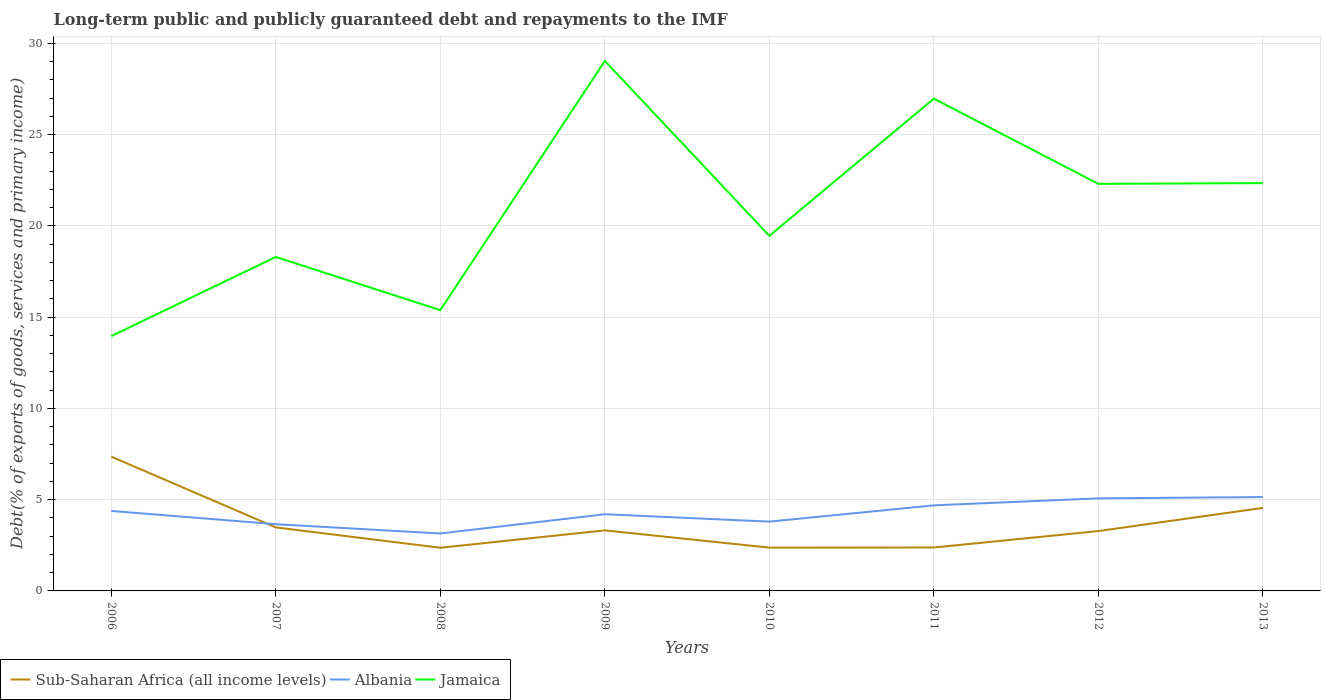Does the line corresponding to Jamaica intersect with the line corresponding to Albania?
Your response must be concise. No. Across all years, what is the maximum debt and repayments in Albania?
Keep it short and to the point. 3.15. What is the total debt and repayments in Jamaica in the graph?
Provide a short and direct response. -11.59. What is the difference between the highest and the second highest debt and repayments in Jamaica?
Make the answer very short. 15.07. Is the debt and repayments in Sub-Saharan Africa (all income levels) strictly greater than the debt and repayments in Albania over the years?
Ensure brevity in your answer.  No. How many lines are there?
Provide a short and direct response. 3. Are the values on the major ticks of Y-axis written in scientific E-notation?
Ensure brevity in your answer.  No. Does the graph contain any zero values?
Provide a succinct answer. No. Does the graph contain grids?
Your answer should be compact. Yes. How many legend labels are there?
Ensure brevity in your answer.  3. What is the title of the graph?
Provide a succinct answer. Long-term public and publicly guaranteed debt and repayments to the IMF. What is the label or title of the Y-axis?
Your answer should be very brief. Debt(% of exports of goods, services and primary income). What is the Debt(% of exports of goods, services and primary income) of Sub-Saharan Africa (all income levels) in 2006?
Make the answer very short. 7.35. What is the Debt(% of exports of goods, services and primary income) in Albania in 2006?
Your answer should be compact. 4.38. What is the Debt(% of exports of goods, services and primary income) in Jamaica in 2006?
Your answer should be compact. 13.96. What is the Debt(% of exports of goods, services and primary income) in Sub-Saharan Africa (all income levels) in 2007?
Give a very brief answer. 3.48. What is the Debt(% of exports of goods, services and primary income) in Albania in 2007?
Keep it short and to the point. 3.66. What is the Debt(% of exports of goods, services and primary income) of Jamaica in 2007?
Provide a succinct answer. 18.29. What is the Debt(% of exports of goods, services and primary income) of Sub-Saharan Africa (all income levels) in 2008?
Your answer should be compact. 2.36. What is the Debt(% of exports of goods, services and primary income) in Albania in 2008?
Provide a succinct answer. 3.15. What is the Debt(% of exports of goods, services and primary income) in Jamaica in 2008?
Your answer should be very brief. 15.38. What is the Debt(% of exports of goods, services and primary income) in Sub-Saharan Africa (all income levels) in 2009?
Keep it short and to the point. 3.32. What is the Debt(% of exports of goods, services and primary income) of Albania in 2009?
Make the answer very short. 4.2. What is the Debt(% of exports of goods, services and primary income) in Jamaica in 2009?
Your response must be concise. 29.03. What is the Debt(% of exports of goods, services and primary income) in Sub-Saharan Africa (all income levels) in 2010?
Offer a very short reply. 2.37. What is the Debt(% of exports of goods, services and primary income) of Albania in 2010?
Provide a succinct answer. 3.8. What is the Debt(% of exports of goods, services and primary income) in Jamaica in 2010?
Your response must be concise. 19.45. What is the Debt(% of exports of goods, services and primary income) of Sub-Saharan Africa (all income levels) in 2011?
Keep it short and to the point. 2.38. What is the Debt(% of exports of goods, services and primary income) of Albania in 2011?
Your answer should be very brief. 4.69. What is the Debt(% of exports of goods, services and primary income) in Jamaica in 2011?
Your answer should be compact. 26.97. What is the Debt(% of exports of goods, services and primary income) of Sub-Saharan Africa (all income levels) in 2012?
Ensure brevity in your answer.  3.28. What is the Debt(% of exports of goods, services and primary income) of Albania in 2012?
Your answer should be very brief. 5.07. What is the Debt(% of exports of goods, services and primary income) of Jamaica in 2012?
Provide a succinct answer. 22.3. What is the Debt(% of exports of goods, services and primary income) in Sub-Saharan Africa (all income levels) in 2013?
Keep it short and to the point. 4.55. What is the Debt(% of exports of goods, services and primary income) in Albania in 2013?
Ensure brevity in your answer.  5.14. What is the Debt(% of exports of goods, services and primary income) in Jamaica in 2013?
Offer a terse response. 22.34. Across all years, what is the maximum Debt(% of exports of goods, services and primary income) in Sub-Saharan Africa (all income levels)?
Ensure brevity in your answer.  7.35. Across all years, what is the maximum Debt(% of exports of goods, services and primary income) of Albania?
Ensure brevity in your answer.  5.14. Across all years, what is the maximum Debt(% of exports of goods, services and primary income) in Jamaica?
Make the answer very short. 29.03. Across all years, what is the minimum Debt(% of exports of goods, services and primary income) of Sub-Saharan Africa (all income levels)?
Ensure brevity in your answer.  2.36. Across all years, what is the minimum Debt(% of exports of goods, services and primary income) of Albania?
Keep it short and to the point. 3.15. Across all years, what is the minimum Debt(% of exports of goods, services and primary income) in Jamaica?
Your answer should be compact. 13.96. What is the total Debt(% of exports of goods, services and primary income) of Sub-Saharan Africa (all income levels) in the graph?
Make the answer very short. 29.09. What is the total Debt(% of exports of goods, services and primary income) of Albania in the graph?
Provide a succinct answer. 34.08. What is the total Debt(% of exports of goods, services and primary income) in Jamaica in the graph?
Offer a terse response. 167.72. What is the difference between the Debt(% of exports of goods, services and primary income) of Sub-Saharan Africa (all income levels) in 2006 and that in 2007?
Your answer should be very brief. 3.88. What is the difference between the Debt(% of exports of goods, services and primary income) in Albania in 2006 and that in 2007?
Provide a succinct answer. 0.73. What is the difference between the Debt(% of exports of goods, services and primary income) in Jamaica in 2006 and that in 2007?
Give a very brief answer. -4.34. What is the difference between the Debt(% of exports of goods, services and primary income) in Sub-Saharan Africa (all income levels) in 2006 and that in 2008?
Give a very brief answer. 4.99. What is the difference between the Debt(% of exports of goods, services and primary income) in Albania in 2006 and that in 2008?
Make the answer very short. 1.23. What is the difference between the Debt(% of exports of goods, services and primary income) in Jamaica in 2006 and that in 2008?
Provide a short and direct response. -1.42. What is the difference between the Debt(% of exports of goods, services and primary income) of Sub-Saharan Africa (all income levels) in 2006 and that in 2009?
Your response must be concise. 4.04. What is the difference between the Debt(% of exports of goods, services and primary income) in Albania in 2006 and that in 2009?
Offer a very short reply. 0.18. What is the difference between the Debt(% of exports of goods, services and primary income) in Jamaica in 2006 and that in 2009?
Ensure brevity in your answer.  -15.07. What is the difference between the Debt(% of exports of goods, services and primary income) of Sub-Saharan Africa (all income levels) in 2006 and that in 2010?
Provide a succinct answer. 4.98. What is the difference between the Debt(% of exports of goods, services and primary income) of Albania in 2006 and that in 2010?
Your answer should be compact. 0.58. What is the difference between the Debt(% of exports of goods, services and primary income) of Jamaica in 2006 and that in 2010?
Your response must be concise. -5.49. What is the difference between the Debt(% of exports of goods, services and primary income) of Sub-Saharan Africa (all income levels) in 2006 and that in 2011?
Make the answer very short. 4.98. What is the difference between the Debt(% of exports of goods, services and primary income) of Albania in 2006 and that in 2011?
Give a very brief answer. -0.31. What is the difference between the Debt(% of exports of goods, services and primary income) of Jamaica in 2006 and that in 2011?
Offer a terse response. -13.01. What is the difference between the Debt(% of exports of goods, services and primary income) in Sub-Saharan Africa (all income levels) in 2006 and that in 2012?
Offer a very short reply. 4.07. What is the difference between the Debt(% of exports of goods, services and primary income) in Albania in 2006 and that in 2012?
Offer a terse response. -0.69. What is the difference between the Debt(% of exports of goods, services and primary income) of Jamaica in 2006 and that in 2012?
Give a very brief answer. -8.34. What is the difference between the Debt(% of exports of goods, services and primary income) of Sub-Saharan Africa (all income levels) in 2006 and that in 2013?
Provide a succinct answer. 2.81. What is the difference between the Debt(% of exports of goods, services and primary income) of Albania in 2006 and that in 2013?
Your answer should be compact. -0.76. What is the difference between the Debt(% of exports of goods, services and primary income) in Jamaica in 2006 and that in 2013?
Ensure brevity in your answer.  -8.38. What is the difference between the Debt(% of exports of goods, services and primary income) of Sub-Saharan Africa (all income levels) in 2007 and that in 2008?
Your response must be concise. 1.11. What is the difference between the Debt(% of exports of goods, services and primary income) of Albania in 2007 and that in 2008?
Your response must be concise. 0.51. What is the difference between the Debt(% of exports of goods, services and primary income) in Jamaica in 2007 and that in 2008?
Give a very brief answer. 2.91. What is the difference between the Debt(% of exports of goods, services and primary income) in Sub-Saharan Africa (all income levels) in 2007 and that in 2009?
Keep it short and to the point. 0.16. What is the difference between the Debt(% of exports of goods, services and primary income) in Albania in 2007 and that in 2009?
Make the answer very short. -0.55. What is the difference between the Debt(% of exports of goods, services and primary income) in Jamaica in 2007 and that in 2009?
Give a very brief answer. -10.74. What is the difference between the Debt(% of exports of goods, services and primary income) of Sub-Saharan Africa (all income levels) in 2007 and that in 2010?
Make the answer very short. 1.11. What is the difference between the Debt(% of exports of goods, services and primary income) of Albania in 2007 and that in 2010?
Provide a short and direct response. -0.14. What is the difference between the Debt(% of exports of goods, services and primary income) of Jamaica in 2007 and that in 2010?
Keep it short and to the point. -1.15. What is the difference between the Debt(% of exports of goods, services and primary income) of Sub-Saharan Africa (all income levels) in 2007 and that in 2011?
Your answer should be very brief. 1.1. What is the difference between the Debt(% of exports of goods, services and primary income) in Albania in 2007 and that in 2011?
Keep it short and to the point. -1.03. What is the difference between the Debt(% of exports of goods, services and primary income) of Jamaica in 2007 and that in 2011?
Offer a terse response. -8.67. What is the difference between the Debt(% of exports of goods, services and primary income) of Sub-Saharan Africa (all income levels) in 2007 and that in 2012?
Your answer should be very brief. 0.2. What is the difference between the Debt(% of exports of goods, services and primary income) in Albania in 2007 and that in 2012?
Your answer should be very brief. -1.42. What is the difference between the Debt(% of exports of goods, services and primary income) in Jamaica in 2007 and that in 2012?
Ensure brevity in your answer.  -4. What is the difference between the Debt(% of exports of goods, services and primary income) of Sub-Saharan Africa (all income levels) in 2007 and that in 2013?
Ensure brevity in your answer.  -1.07. What is the difference between the Debt(% of exports of goods, services and primary income) in Albania in 2007 and that in 2013?
Your answer should be compact. -1.49. What is the difference between the Debt(% of exports of goods, services and primary income) of Jamaica in 2007 and that in 2013?
Offer a very short reply. -4.05. What is the difference between the Debt(% of exports of goods, services and primary income) of Sub-Saharan Africa (all income levels) in 2008 and that in 2009?
Keep it short and to the point. -0.95. What is the difference between the Debt(% of exports of goods, services and primary income) of Albania in 2008 and that in 2009?
Give a very brief answer. -1.05. What is the difference between the Debt(% of exports of goods, services and primary income) in Jamaica in 2008 and that in 2009?
Offer a terse response. -13.65. What is the difference between the Debt(% of exports of goods, services and primary income) in Sub-Saharan Africa (all income levels) in 2008 and that in 2010?
Your response must be concise. -0.01. What is the difference between the Debt(% of exports of goods, services and primary income) of Albania in 2008 and that in 2010?
Make the answer very short. -0.65. What is the difference between the Debt(% of exports of goods, services and primary income) in Jamaica in 2008 and that in 2010?
Offer a very short reply. -4.07. What is the difference between the Debt(% of exports of goods, services and primary income) in Sub-Saharan Africa (all income levels) in 2008 and that in 2011?
Your answer should be very brief. -0.01. What is the difference between the Debt(% of exports of goods, services and primary income) of Albania in 2008 and that in 2011?
Give a very brief answer. -1.54. What is the difference between the Debt(% of exports of goods, services and primary income) of Jamaica in 2008 and that in 2011?
Keep it short and to the point. -11.59. What is the difference between the Debt(% of exports of goods, services and primary income) of Sub-Saharan Africa (all income levels) in 2008 and that in 2012?
Make the answer very short. -0.91. What is the difference between the Debt(% of exports of goods, services and primary income) in Albania in 2008 and that in 2012?
Your answer should be compact. -1.92. What is the difference between the Debt(% of exports of goods, services and primary income) of Jamaica in 2008 and that in 2012?
Provide a succinct answer. -6.92. What is the difference between the Debt(% of exports of goods, services and primary income) of Sub-Saharan Africa (all income levels) in 2008 and that in 2013?
Your response must be concise. -2.18. What is the difference between the Debt(% of exports of goods, services and primary income) of Albania in 2008 and that in 2013?
Provide a succinct answer. -1.99. What is the difference between the Debt(% of exports of goods, services and primary income) of Jamaica in 2008 and that in 2013?
Provide a succinct answer. -6.96. What is the difference between the Debt(% of exports of goods, services and primary income) of Sub-Saharan Africa (all income levels) in 2009 and that in 2010?
Give a very brief answer. 0.95. What is the difference between the Debt(% of exports of goods, services and primary income) in Albania in 2009 and that in 2010?
Provide a short and direct response. 0.4. What is the difference between the Debt(% of exports of goods, services and primary income) in Jamaica in 2009 and that in 2010?
Offer a very short reply. 9.58. What is the difference between the Debt(% of exports of goods, services and primary income) of Sub-Saharan Africa (all income levels) in 2009 and that in 2011?
Offer a terse response. 0.94. What is the difference between the Debt(% of exports of goods, services and primary income) of Albania in 2009 and that in 2011?
Give a very brief answer. -0.49. What is the difference between the Debt(% of exports of goods, services and primary income) in Jamaica in 2009 and that in 2011?
Your response must be concise. 2.07. What is the difference between the Debt(% of exports of goods, services and primary income) of Sub-Saharan Africa (all income levels) in 2009 and that in 2012?
Keep it short and to the point. 0.04. What is the difference between the Debt(% of exports of goods, services and primary income) of Albania in 2009 and that in 2012?
Your response must be concise. -0.87. What is the difference between the Debt(% of exports of goods, services and primary income) of Jamaica in 2009 and that in 2012?
Your answer should be compact. 6.73. What is the difference between the Debt(% of exports of goods, services and primary income) in Sub-Saharan Africa (all income levels) in 2009 and that in 2013?
Provide a short and direct response. -1.23. What is the difference between the Debt(% of exports of goods, services and primary income) in Albania in 2009 and that in 2013?
Give a very brief answer. -0.94. What is the difference between the Debt(% of exports of goods, services and primary income) of Jamaica in 2009 and that in 2013?
Your response must be concise. 6.69. What is the difference between the Debt(% of exports of goods, services and primary income) in Sub-Saharan Africa (all income levels) in 2010 and that in 2011?
Offer a terse response. -0.01. What is the difference between the Debt(% of exports of goods, services and primary income) in Albania in 2010 and that in 2011?
Make the answer very short. -0.89. What is the difference between the Debt(% of exports of goods, services and primary income) in Jamaica in 2010 and that in 2011?
Make the answer very short. -7.52. What is the difference between the Debt(% of exports of goods, services and primary income) of Sub-Saharan Africa (all income levels) in 2010 and that in 2012?
Your response must be concise. -0.91. What is the difference between the Debt(% of exports of goods, services and primary income) of Albania in 2010 and that in 2012?
Provide a short and direct response. -1.27. What is the difference between the Debt(% of exports of goods, services and primary income) in Jamaica in 2010 and that in 2012?
Offer a very short reply. -2.85. What is the difference between the Debt(% of exports of goods, services and primary income) in Sub-Saharan Africa (all income levels) in 2010 and that in 2013?
Your response must be concise. -2.18. What is the difference between the Debt(% of exports of goods, services and primary income) of Albania in 2010 and that in 2013?
Offer a very short reply. -1.35. What is the difference between the Debt(% of exports of goods, services and primary income) in Jamaica in 2010 and that in 2013?
Your answer should be very brief. -2.89. What is the difference between the Debt(% of exports of goods, services and primary income) of Sub-Saharan Africa (all income levels) in 2011 and that in 2012?
Make the answer very short. -0.9. What is the difference between the Debt(% of exports of goods, services and primary income) of Albania in 2011 and that in 2012?
Provide a succinct answer. -0.38. What is the difference between the Debt(% of exports of goods, services and primary income) in Jamaica in 2011 and that in 2012?
Keep it short and to the point. 4.67. What is the difference between the Debt(% of exports of goods, services and primary income) in Sub-Saharan Africa (all income levels) in 2011 and that in 2013?
Keep it short and to the point. -2.17. What is the difference between the Debt(% of exports of goods, services and primary income) in Albania in 2011 and that in 2013?
Your answer should be compact. -0.45. What is the difference between the Debt(% of exports of goods, services and primary income) in Jamaica in 2011 and that in 2013?
Ensure brevity in your answer.  4.62. What is the difference between the Debt(% of exports of goods, services and primary income) in Sub-Saharan Africa (all income levels) in 2012 and that in 2013?
Your response must be concise. -1.27. What is the difference between the Debt(% of exports of goods, services and primary income) in Albania in 2012 and that in 2013?
Provide a succinct answer. -0.07. What is the difference between the Debt(% of exports of goods, services and primary income) in Jamaica in 2012 and that in 2013?
Your response must be concise. -0.04. What is the difference between the Debt(% of exports of goods, services and primary income) in Sub-Saharan Africa (all income levels) in 2006 and the Debt(% of exports of goods, services and primary income) in Albania in 2007?
Offer a terse response. 3.7. What is the difference between the Debt(% of exports of goods, services and primary income) of Sub-Saharan Africa (all income levels) in 2006 and the Debt(% of exports of goods, services and primary income) of Jamaica in 2007?
Keep it short and to the point. -10.94. What is the difference between the Debt(% of exports of goods, services and primary income) in Albania in 2006 and the Debt(% of exports of goods, services and primary income) in Jamaica in 2007?
Offer a very short reply. -13.91. What is the difference between the Debt(% of exports of goods, services and primary income) in Sub-Saharan Africa (all income levels) in 2006 and the Debt(% of exports of goods, services and primary income) in Albania in 2008?
Your answer should be compact. 4.21. What is the difference between the Debt(% of exports of goods, services and primary income) of Sub-Saharan Africa (all income levels) in 2006 and the Debt(% of exports of goods, services and primary income) of Jamaica in 2008?
Keep it short and to the point. -8.03. What is the difference between the Debt(% of exports of goods, services and primary income) in Albania in 2006 and the Debt(% of exports of goods, services and primary income) in Jamaica in 2008?
Your answer should be very brief. -11. What is the difference between the Debt(% of exports of goods, services and primary income) in Sub-Saharan Africa (all income levels) in 2006 and the Debt(% of exports of goods, services and primary income) in Albania in 2009?
Offer a terse response. 3.15. What is the difference between the Debt(% of exports of goods, services and primary income) of Sub-Saharan Africa (all income levels) in 2006 and the Debt(% of exports of goods, services and primary income) of Jamaica in 2009?
Offer a terse response. -21.68. What is the difference between the Debt(% of exports of goods, services and primary income) in Albania in 2006 and the Debt(% of exports of goods, services and primary income) in Jamaica in 2009?
Your response must be concise. -24.65. What is the difference between the Debt(% of exports of goods, services and primary income) of Sub-Saharan Africa (all income levels) in 2006 and the Debt(% of exports of goods, services and primary income) of Albania in 2010?
Offer a terse response. 3.56. What is the difference between the Debt(% of exports of goods, services and primary income) of Sub-Saharan Africa (all income levels) in 2006 and the Debt(% of exports of goods, services and primary income) of Jamaica in 2010?
Make the answer very short. -12.1. What is the difference between the Debt(% of exports of goods, services and primary income) in Albania in 2006 and the Debt(% of exports of goods, services and primary income) in Jamaica in 2010?
Make the answer very short. -15.07. What is the difference between the Debt(% of exports of goods, services and primary income) of Sub-Saharan Africa (all income levels) in 2006 and the Debt(% of exports of goods, services and primary income) of Albania in 2011?
Make the answer very short. 2.67. What is the difference between the Debt(% of exports of goods, services and primary income) in Sub-Saharan Africa (all income levels) in 2006 and the Debt(% of exports of goods, services and primary income) in Jamaica in 2011?
Provide a short and direct response. -19.61. What is the difference between the Debt(% of exports of goods, services and primary income) of Albania in 2006 and the Debt(% of exports of goods, services and primary income) of Jamaica in 2011?
Your answer should be compact. -22.59. What is the difference between the Debt(% of exports of goods, services and primary income) in Sub-Saharan Africa (all income levels) in 2006 and the Debt(% of exports of goods, services and primary income) in Albania in 2012?
Make the answer very short. 2.28. What is the difference between the Debt(% of exports of goods, services and primary income) of Sub-Saharan Africa (all income levels) in 2006 and the Debt(% of exports of goods, services and primary income) of Jamaica in 2012?
Ensure brevity in your answer.  -14.94. What is the difference between the Debt(% of exports of goods, services and primary income) of Albania in 2006 and the Debt(% of exports of goods, services and primary income) of Jamaica in 2012?
Provide a short and direct response. -17.92. What is the difference between the Debt(% of exports of goods, services and primary income) in Sub-Saharan Africa (all income levels) in 2006 and the Debt(% of exports of goods, services and primary income) in Albania in 2013?
Give a very brief answer. 2.21. What is the difference between the Debt(% of exports of goods, services and primary income) in Sub-Saharan Africa (all income levels) in 2006 and the Debt(% of exports of goods, services and primary income) in Jamaica in 2013?
Provide a succinct answer. -14.99. What is the difference between the Debt(% of exports of goods, services and primary income) of Albania in 2006 and the Debt(% of exports of goods, services and primary income) of Jamaica in 2013?
Make the answer very short. -17.96. What is the difference between the Debt(% of exports of goods, services and primary income) in Sub-Saharan Africa (all income levels) in 2007 and the Debt(% of exports of goods, services and primary income) in Albania in 2008?
Your answer should be very brief. 0.33. What is the difference between the Debt(% of exports of goods, services and primary income) in Sub-Saharan Africa (all income levels) in 2007 and the Debt(% of exports of goods, services and primary income) in Jamaica in 2008?
Make the answer very short. -11.9. What is the difference between the Debt(% of exports of goods, services and primary income) of Albania in 2007 and the Debt(% of exports of goods, services and primary income) of Jamaica in 2008?
Offer a terse response. -11.72. What is the difference between the Debt(% of exports of goods, services and primary income) of Sub-Saharan Africa (all income levels) in 2007 and the Debt(% of exports of goods, services and primary income) of Albania in 2009?
Make the answer very short. -0.72. What is the difference between the Debt(% of exports of goods, services and primary income) in Sub-Saharan Africa (all income levels) in 2007 and the Debt(% of exports of goods, services and primary income) in Jamaica in 2009?
Offer a very short reply. -25.55. What is the difference between the Debt(% of exports of goods, services and primary income) of Albania in 2007 and the Debt(% of exports of goods, services and primary income) of Jamaica in 2009?
Offer a very short reply. -25.38. What is the difference between the Debt(% of exports of goods, services and primary income) in Sub-Saharan Africa (all income levels) in 2007 and the Debt(% of exports of goods, services and primary income) in Albania in 2010?
Give a very brief answer. -0.32. What is the difference between the Debt(% of exports of goods, services and primary income) in Sub-Saharan Africa (all income levels) in 2007 and the Debt(% of exports of goods, services and primary income) in Jamaica in 2010?
Offer a very short reply. -15.97. What is the difference between the Debt(% of exports of goods, services and primary income) in Albania in 2007 and the Debt(% of exports of goods, services and primary income) in Jamaica in 2010?
Give a very brief answer. -15.79. What is the difference between the Debt(% of exports of goods, services and primary income) in Sub-Saharan Africa (all income levels) in 2007 and the Debt(% of exports of goods, services and primary income) in Albania in 2011?
Offer a terse response. -1.21. What is the difference between the Debt(% of exports of goods, services and primary income) in Sub-Saharan Africa (all income levels) in 2007 and the Debt(% of exports of goods, services and primary income) in Jamaica in 2011?
Your answer should be compact. -23.49. What is the difference between the Debt(% of exports of goods, services and primary income) of Albania in 2007 and the Debt(% of exports of goods, services and primary income) of Jamaica in 2011?
Keep it short and to the point. -23.31. What is the difference between the Debt(% of exports of goods, services and primary income) in Sub-Saharan Africa (all income levels) in 2007 and the Debt(% of exports of goods, services and primary income) in Albania in 2012?
Give a very brief answer. -1.59. What is the difference between the Debt(% of exports of goods, services and primary income) in Sub-Saharan Africa (all income levels) in 2007 and the Debt(% of exports of goods, services and primary income) in Jamaica in 2012?
Make the answer very short. -18.82. What is the difference between the Debt(% of exports of goods, services and primary income) of Albania in 2007 and the Debt(% of exports of goods, services and primary income) of Jamaica in 2012?
Your answer should be compact. -18.64. What is the difference between the Debt(% of exports of goods, services and primary income) of Sub-Saharan Africa (all income levels) in 2007 and the Debt(% of exports of goods, services and primary income) of Albania in 2013?
Your answer should be very brief. -1.66. What is the difference between the Debt(% of exports of goods, services and primary income) in Sub-Saharan Africa (all income levels) in 2007 and the Debt(% of exports of goods, services and primary income) in Jamaica in 2013?
Provide a short and direct response. -18.86. What is the difference between the Debt(% of exports of goods, services and primary income) of Albania in 2007 and the Debt(% of exports of goods, services and primary income) of Jamaica in 2013?
Ensure brevity in your answer.  -18.69. What is the difference between the Debt(% of exports of goods, services and primary income) of Sub-Saharan Africa (all income levels) in 2008 and the Debt(% of exports of goods, services and primary income) of Albania in 2009?
Provide a short and direct response. -1.84. What is the difference between the Debt(% of exports of goods, services and primary income) in Sub-Saharan Africa (all income levels) in 2008 and the Debt(% of exports of goods, services and primary income) in Jamaica in 2009?
Keep it short and to the point. -26.67. What is the difference between the Debt(% of exports of goods, services and primary income) in Albania in 2008 and the Debt(% of exports of goods, services and primary income) in Jamaica in 2009?
Ensure brevity in your answer.  -25.89. What is the difference between the Debt(% of exports of goods, services and primary income) of Sub-Saharan Africa (all income levels) in 2008 and the Debt(% of exports of goods, services and primary income) of Albania in 2010?
Offer a very short reply. -1.43. What is the difference between the Debt(% of exports of goods, services and primary income) in Sub-Saharan Africa (all income levels) in 2008 and the Debt(% of exports of goods, services and primary income) in Jamaica in 2010?
Ensure brevity in your answer.  -17.09. What is the difference between the Debt(% of exports of goods, services and primary income) of Albania in 2008 and the Debt(% of exports of goods, services and primary income) of Jamaica in 2010?
Offer a terse response. -16.3. What is the difference between the Debt(% of exports of goods, services and primary income) of Sub-Saharan Africa (all income levels) in 2008 and the Debt(% of exports of goods, services and primary income) of Albania in 2011?
Give a very brief answer. -2.32. What is the difference between the Debt(% of exports of goods, services and primary income) of Sub-Saharan Africa (all income levels) in 2008 and the Debt(% of exports of goods, services and primary income) of Jamaica in 2011?
Your answer should be compact. -24.6. What is the difference between the Debt(% of exports of goods, services and primary income) in Albania in 2008 and the Debt(% of exports of goods, services and primary income) in Jamaica in 2011?
Offer a terse response. -23.82. What is the difference between the Debt(% of exports of goods, services and primary income) in Sub-Saharan Africa (all income levels) in 2008 and the Debt(% of exports of goods, services and primary income) in Albania in 2012?
Your answer should be compact. -2.71. What is the difference between the Debt(% of exports of goods, services and primary income) in Sub-Saharan Africa (all income levels) in 2008 and the Debt(% of exports of goods, services and primary income) in Jamaica in 2012?
Provide a short and direct response. -19.93. What is the difference between the Debt(% of exports of goods, services and primary income) of Albania in 2008 and the Debt(% of exports of goods, services and primary income) of Jamaica in 2012?
Ensure brevity in your answer.  -19.15. What is the difference between the Debt(% of exports of goods, services and primary income) of Sub-Saharan Africa (all income levels) in 2008 and the Debt(% of exports of goods, services and primary income) of Albania in 2013?
Your response must be concise. -2.78. What is the difference between the Debt(% of exports of goods, services and primary income) of Sub-Saharan Africa (all income levels) in 2008 and the Debt(% of exports of goods, services and primary income) of Jamaica in 2013?
Give a very brief answer. -19.98. What is the difference between the Debt(% of exports of goods, services and primary income) in Albania in 2008 and the Debt(% of exports of goods, services and primary income) in Jamaica in 2013?
Your response must be concise. -19.19. What is the difference between the Debt(% of exports of goods, services and primary income) of Sub-Saharan Africa (all income levels) in 2009 and the Debt(% of exports of goods, services and primary income) of Albania in 2010?
Offer a very short reply. -0.48. What is the difference between the Debt(% of exports of goods, services and primary income) of Sub-Saharan Africa (all income levels) in 2009 and the Debt(% of exports of goods, services and primary income) of Jamaica in 2010?
Keep it short and to the point. -16.13. What is the difference between the Debt(% of exports of goods, services and primary income) in Albania in 2009 and the Debt(% of exports of goods, services and primary income) in Jamaica in 2010?
Your answer should be very brief. -15.25. What is the difference between the Debt(% of exports of goods, services and primary income) in Sub-Saharan Africa (all income levels) in 2009 and the Debt(% of exports of goods, services and primary income) in Albania in 2011?
Keep it short and to the point. -1.37. What is the difference between the Debt(% of exports of goods, services and primary income) of Sub-Saharan Africa (all income levels) in 2009 and the Debt(% of exports of goods, services and primary income) of Jamaica in 2011?
Your answer should be very brief. -23.65. What is the difference between the Debt(% of exports of goods, services and primary income) of Albania in 2009 and the Debt(% of exports of goods, services and primary income) of Jamaica in 2011?
Your response must be concise. -22.77. What is the difference between the Debt(% of exports of goods, services and primary income) in Sub-Saharan Africa (all income levels) in 2009 and the Debt(% of exports of goods, services and primary income) in Albania in 2012?
Ensure brevity in your answer.  -1.75. What is the difference between the Debt(% of exports of goods, services and primary income) of Sub-Saharan Africa (all income levels) in 2009 and the Debt(% of exports of goods, services and primary income) of Jamaica in 2012?
Your answer should be very brief. -18.98. What is the difference between the Debt(% of exports of goods, services and primary income) of Albania in 2009 and the Debt(% of exports of goods, services and primary income) of Jamaica in 2012?
Give a very brief answer. -18.1. What is the difference between the Debt(% of exports of goods, services and primary income) of Sub-Saharan Africa (all income levels) in 2009 and the Debt(% of exports of goods, services and primary income) of Albania in 2013?
Keep it short and to the point. -1.83. What is the difference between the Debt(% of exports of goods, services and primary income) in Sub-Saharan Africa (all income levels) in 2009 and the Debt(% of exports of goods, services and primary income) in Jamaica in 2013?
Provide a short and direct response. -19.02. What is the difference between the Debt(% of exports of goods, services and primary income) of Albania in 2009 and the Debt(% of exports of goods, services and primary income) of Jamaica in 2013?
Provide a short and direct response. -18.14. What is the difference between the Debt(% of exports of goods, services and primary income) of Sub-Saharan Africa (all income levels) in 2010 and the Debt(% of exports of goods, services and primary income) of Albania in 2011?
Keep it short and to the point. -2.32. What is the difference between the Debt(% of exports of goods, services and primary income) in Sub-Saharan Africa (all income levels) in 2010 and the Debt(% of exports of goods, services and primary income) in Jamaica in 2011?
Provide a short and direct response. -24.59. What is the difference between the Debt(% of exports of goods, services and primary income) in Albania in 2010 and the Debt(% of exports of goods, services and primary income) in Jamaica in 2011?
Provide a short and direct response. -23.17. What is the difference between the Debt(% of exports of goods, services and primary income) of Sub-Saharan Africa (all income levels) in 2010 and the Debt(% of exports of goods, services and primary income) of Albania in 2012?
Provide a short and direct response. -2.7. What is the difference between the Debt(% of exports of goods, services and primary income) in Sub-Saharan Africa (all income levels) in 2010 and the Debt(% of exports of goods, services and primary income) in Jamaica in 2012?
Your answer should be compact. -19.93. What is the difference between the Debt(% of exports of goods, services and primary income) of Albania in 2010 and the Debt(% of exports of goods, services and primary income) of Jamaica in 2012?
Ensure brevity in your answer.  -18.5. What is the difference between the Debt(% of exports of goods, services and primary income) in Sub-Saharan Africa (all income levels) in 2010 and the Debt(% of exports of goods, services and primary income) in Albania in 2013?
Offer a very short reply. -2.77. What is the difference between the Debt(% of exports of goods, services and primary income) in Sub-Saharan Africa (all income levels) in 2010 and the Debt(% of exports of goods, services and primary income) in Jamaica in 2013?
Your response must be concise. -19.97. What is the difference between the Debt(% of exports of goods, services and primary income) of Albania in 2010 and the Debt(% of exports of goods, services and primary income) of Jamaica in 2013?
Offer a very short reply. -18.54. What is the difference between the Debt(% of exports of goods, services and primary income) in Sub-Saharan Africa (all income levels) in 2011 and the Debt(% of exports of goods, services and primary income) in Albania in 2012?
Provide a succinct answer. -2.69. What is the difference between the Debt(% of exports of goods, services and primary income) of Sub-Saharan Africa (all income levels) in 2011 and the Debt(% of exports of goods, services and primary income) of Jamaica in 2012?
Make the answer very short. -19.92. What is the difference between the Debt(% of exports of goods, services and primary income) in Albania in 2011 and the Debt(% of exports of goods, services and primary income) in Jamaica in 2012?
Your answer should be very brief. -17.61. What is the difference between the Debt(% of exports of goods, services and primary income) in Sub-Saharan Africa (all income levels) in 2011 and the Debt(% of exports of goods, services and primary income) in Albania in 2013?
Offer a terse response. -2.76. What is the difference between the Debt(% of exports of goods, services and primary income) in Sub-Saharan Africa (all income levels) in 2011 and the Debt(% of exports of goods, services and primary income) in Jamaica in 2013?
Provide a succinct answer. -19.96. What is the difference between the Debt(% of exports of goods, services and primary income) of Albania in 2011 and the Debt(% of exports of goods, services and primary income) of Jamaica in 2013?
Your response must be concise. -17.65. What is the difference between the Debt(% of exports of goods, services and primary income) in Sub-Saharan Africa (all income levels) in 2012 and the Debt(% of exports of goods, services and primary income) in Albania in 2013?
Your response must be concise. -1.86. What is the difference between the Debt(% of exports of goods, services and primary income) of Sub-Saharan Africa (all income levels) in 2012 and the Debt(% of exports of goods, services and primary income) of Jamaica in 2013?
Give a very brief answer. -19.06. What is the difference between the Debt(% of exports of goods, services and primary income) in Albania in 2012 and the Debt(% of exports of goods, services and primary income) in Jamaica in 2013?
Your response must be concise. -17.27. What is the average Debt(% of exports of goods, services and primary income) of Sub-Saharan Africa (all income levels) per year?
Make the answer very short. 3.64. What is the average Debt(% of exports of goods, services and primary income) of Albania per year?
Your answer should be compact. 4.26. What is the average Debt(% of exports of goods, services and primary income) of Jamaica per year?
Offer a very short reply. 20.97. In the year 2006, what is the difference between the Debt(% of exports of goods, services and primary income) of Sub-Saharan Africa (all income levels) and Debt(% of exports of goods, services and primary income) of Albania?
Your response must be concise. 2.97. In the year 2006, what is the difference between the Debt(% of exports of goods, services and primary income) of Sub-Saharan Africa (all income levels) and Debt(% of exports of goods, services and primary income) of Jamaica?
Offer a very short reply. -6.61. In the year 2006, what is the difference between the Debt(% of exports of goods, services and primary income) of Albania and Debt(% of exports of goods, services and primary income) of Jamaica?
Make the answer very short. -9.58. In the year 2007, what is the difference between the Debt(% of exports of goods, services and primary income) of Sub-Saharan Africa (all income levels) and Debt(% of exports of goods, services and primary income) of Albania?
Provide a short and direct response. -0.18. In the year 2007, what is the difference between the Debt(% of exports of goods, services and primary income) of Sub-Saharan Africa (all income levels) and Debt(% of exports of goods, services and primary income) of Jamaica?
Offer a terse response. -14.82. In the year 2007, what is the difference between the Debt(% of exports of goods, services and primary income) of Albania and Debt(% of exports of goods, services and primary income) of Jamaica?
Give a very brief answer. -14.64. In the year 2008, what is the difference between the Debt(% of exports of goods, services and primary income) of Sub-Saharan Africa (all income levels) and Debt(% of exports of goods, services and primary income) of Albania?
Make the answer very short. -0.78. In the year 2008, what is the difference between the Debt(% of exports of goods, services and primary income) in Sub-Saharan Africa (all income levels) and Debt(% of exports of goods, services and primary income) in Jamaica?
Offer a very short reply. -13.02. In the year 2008, what is the difference between the Debt(% of exports of goods, services and primary income) in Albania and Debt(% of exports of goods, services and primary income) in Jamaica?
Ensure brevity in your answer.  -12.23. In the year 2009, what is the difference between the Debt(% of exports of goods, services and primary income) in Sub-Saharan Africa (all income levels) and Debt(% of exports of goods, services and primary income) in Albania?
Offer a very short reply. -0.88. In the year 2009, what is the difference between the Debt(% of exports of goods, services and primary income) in Sub-Saharan Africa (all income levels) and Debt(% of exports of goods, services and primary income) in Jamaica?
Ensure brevity in your answer.  -25.72. In the year 2009, what is the difference between the Debt(% of exports of goods, services and primary income) in Albania and Debt(% of exports of goods, services and primary income) in Jamaica?
Make the answer very short. -24.83. In the year 2010, what is the difference between the Debt(% of exports of goods, services and primary income) in Sub-Saharan Africa (all income levels) and Debt(% of exports of goods, services and primary income) in Albania?
Give a very brief answer. -1.43. In the year 2010, what is the difference between the Debt(% of exports of goods, services and primary income) in Sub-Saharan Africa (all income levels) and Debt(% of exports of goods, services and primary income) in Jamaica?
Your answer should be compact. -17.08. In the year 2010, what is the difference between the Debt(% of exports of goods, services and primary income) in Albania and Debt(% of exports of goods, services and primary income) in Jamaica?
Keep it short and to the point. -15.65. In the year 2011, what is the difference between the Debt(% of exports of goods, services and primary income) in Sub-Saharan Africa (all income levels) and Debt(% of exports of goods, services and primary income) in Albania?
Provide a succinct answer. -2.31. In the year 2011, what is the difference between the Debt(% of exports of goods, services and primary income) in Sub-Saharan Africa (all income levels) and Debt(% of exports of goods, services and primary income) in Jamaica?
Your response must be concise. -24.59. In the year 2011, what is the difference between the Debt(% of exports of goods, services and primary income) in Albania and Debt(% of exports of goods, services and primary income) in Jamaica?
Provide a succinct answer. -22.28. In the year 2012, what is the difference between the Debt(% of exports of goods, services and primary income) in Sub-Saharan Africa (all income levels) and Debt(% of exports of goods, services and primary income) in Albania?
Your response must be concise. -1.79. In the year 2012, what is the difference between the Debt(% of exports of goods, services and primary income) of Sub-Saharan Africa (all income levels) and Debt(% of exports of goods, services and primary income) of Jamaica?
Offer a terse response. -19.02. In the year 2012, what is the difference between the Debt(% of exports of goods, services and primary income) of Albania and Debt(% of exports of goods, services and primary income) of Jamaica?
Give a very brief answer. -17.23. In the year 2013, what is the difference between the Debt(% of exports of goods, services and primary income) in Sub-Saharan Africa (all income levels) and Debt(% of exports of goods, services and primary income) in Albania?
Give a very brief answer. -0.59. In the year 2013, what is the difference between the Debt(% of exports of goods, services and primary income) in Sub-Saharan Africa (all income levels) and Debt(% of exports of goods, services and primary income) in Jamaica?
Your answer should be very brief. -17.79. In the year 2013, what is the difference between the Debt(% of exports of goods, services and primary income) in Albania and Debt(% of exports of goods, services and primary income) in Jamaica?
Ensure brevity in your answer.  -17.2. What is the ratio of the Debt(% of exports of goods, services and primary income) of Sub-Saharan Africa (all income levels) in 2006 to that in 2007?
Offer a terse response. 2.11. What is the ratio of the Debt(% of exports of goods, services and primary income) in Albania in 2006 to that in 2007?
Offer a terse response. 1.2. What is the ratio of the Debt(% of exports of goods, services and primary income) in Jamaica in 2006 to that in 2007?
Provide a succinct answer. 0.76. What is the ratio of the Debt(% of exports of goods, services and primary income) of Sub-Saharan Africa (all income levels) in 2006 to that in 2008?
Make the answer very short. 3.11. What is the ratio of the Debt(% of exports of goods, services and primary income) in Albania in 2006 to that in 2008?
Your answer should be compact. 1.39. What is the ratio of the Debt(% of exports of goods, services and primary income) of Jamaica in 2006 to that in 2008?
Offer a terse response. 0.91. What is the ratio of the Debt(% of exports of goods, services and primary income) in Sub-Saharan Africa (all income levels) in 2006 to that in 2009?
Give a very brief answer. 2.22. What is the ratio of the Debt(% of exports of goods, services and primary income) in Albania in 2006 to that in 2009?
Provide a short and direct response. 1.04. What is the ratio of the Debt(% of exports of goods, services and primary income) in Jamaica in 2006 to that in 2009?
Provide a short and direct response. 0.48. What is the ratio of the Debt(% of exports of goods, services and primary income) of Sub-Saharan Africa (all income levels) in 2006 to that in 2010?
Offer a very short reply. 3.1. What is the ratio of the Debt(% of exports of goods, services and primary income) of Albania in 2006 to that in 2010?
Keep it short and to the point. 1.15. What is the ratio of the Debt(% of exports of goods, services and primary income) of Jamaica in 2006 to that in 2010?
Offer a terse response. 0.72. What is the ratio of the Debt(% of exports of goods, services and primary income) of Sub-Saharan Africa (all income levels) in 2006 to that in 2011?
Offer a terse response. 3.09. What is the ratio of the Debt(% of exports of goods, services and primary income) in Albania in 2006 to that in 2011?
Make the answer very short. 0.93. What is the ratio of the Debt(% of exports of goods, services and primary income) of Jamaica in 2006 to that in 2011?
Ensure brevity in your answer.  0.52. What is the ratio of the Debt(% of exports of goods, services and primary income) in Sub-Saharan Africa (all income levels) in 2006 to that in 2012?
Make the answer very short. 2.24. What is the ratio of the Debt(% of exports of goods, services and primary income) in Albania in 2006 to that in 2012?
Your answer should be very brief. 0.86. What is the ratio of the Debt(% of exports of goods, services and primary income) of Jamaica in 2006 to that in 2012?
Provide a succinct answer. 0.63. What is the ratio of the Debt(% of exports of goods, services and primary income) of Sub-Saharan Africa (all income levels) in 2006 to that in 2013?
Make the answer very short. 1.62. What is the ratio of the Debt(% of exports of goods, services and primary income) in Albania in 2006 to that in 2013?
Your answer should be compact. 0.85. What is the ratio of the Debt(% of exports of goods, services and primary income) in Jamaica in 2006 to that in 2013?
Provide a succinct answer. 0.62. What is the ratio of the Debt(% of exports of goods, services and primary income) in Sub-Saharan Africa (all income levels) in 2007 to that in 2008?
Offer a terse response. 1.47. What is the ratio of the Debt(% of exports of goods, services and primary income) in Albania in 2007 to that in 2008?
Your answer should be compact. 1.16. What is the ratio of the Debt(% of exports of goods, services and primary income) in Jamaica in 2007 to that in 2008?
Provide a short and direct response. 1.19. What is the ratio of the Debt(% of exports of goods, services and primary income) in Sub-Saharan Africa (all income levels) in 2007 to that in 2009?
Your answer should be very brief. 1.05. What is the ratio of the Debt(% of exports of goods, services and primary income) in Albania in 2007 to that in 2009?
Keep it short and to the point. 0.87. What is the ratio of the Debt(% of exports of goods, services and primary income) in Jamaica in 2007 to that in 2009?
Keep it short and to the point. 0.63. What is the ratio of the Debt(% of exports of goods, services and primary income) in Sub-Saharan Africa (all income levels) in 2007 to that in 2010?
Offer a terse response. 1.47. What is the ratio of the Debt(% of exports of goods, services and primary income) in Albania in 2007 to that in 2010?
Provide a succinct answer. 0.96. What is the ratio of the Debt(% of exports of goods, services and primary income) in Jamaica in 2007 to that in 2010?
Keep it short and to the point. 0.94. What is the ratio of the Debt(% of exports of goods, services and primary income) of Sub-Saharan Africa (all income levels) in 2007 to that in 2011?
Provide a short and direct response. 1.46. What is the ratio of the Debt(% of exports of goods, services and primary income) of Albania in 2007 to that in 2011?
Keep it short and to the point. 0.78. What is the ratio of the Debt(% of exports of goods, services and primary income) of Jamaica in 2007 to that in 2011?
Offer a very short reply. 0.68. What is the ratio of the Debt(% of exports of goods, services and primary income) in Sub-Saharan Africa (all income levels) in 2007 to that in 2012?
Provide a short and direct response. 1.06. What is the ratio of the Debt(% of exports of goods, services and primary income) in Albania in 2007 to that in 2012?
Provide a succinct answer. 0.72. What is the ratio of the Debt(% of exports of goods, services and primary income) in Jamaica in 2007 to that in 2012?
Your answer should be very brief. 0.82. What is the ratio of the Debt(% of exports of goods, services and primary income) of Sub-Saharan Africa (all income levels) in 2007 to that in 2013?
Your answer should be very brief. 0.76. What is the ratio of the Debt(% of exports of goods, services and primary income) of Albania in 2007 to that in 2013?
Provide a succinct answer. 0.71. What is the ratio of the Debt(% of exports of goods, services and primary income) of Jamaica in 2007 to that in 2013?
Make the answer very short. 0.82. What is the ratio of the Debt(% of exports of goods, services and primary income) of Sub-Saharan Africa (all income levels) in 2008 to that in 2009?
Offer a very short reply. 0.71. What is the ratio of the Debt(% of exports of goods, services and primary income) in Albania in 2008 to that in 2009?
Give a very brief answer. 0.75. What is the ratio of the Debt(% of exports of goods, services and primary income) in Jamaica in 2008 to that in 2009?
Offer a very short reply. 0.53. What is the ratio of the Debt(% of exports of goods, services and primary income) of Sub-Saharan Africa (all income levels) in 2008 to that in 2010?
Keep it short and to the point. 1. What is the ratio of the Debt(% of exports of goods, services and primary income) of Albania in 2008 to that in 2010?
Provide a short and direct response. 0.83. What is the ratio of the Debt(% of exports of goods, services and primary income) of Jamaica in 2008 to that in 2010?
Make the answer very short. 0.79. What is the ratio of the Debt(% of exports of goods, services and primary income) of Albania in 2008 to that in 2011?
Offer a terse response. 0.67. What is the ratio of the Debt(% of exports of goods, services and primary income) in Jamaica in 2008 to that in 2011?
Offer a terse response. 0.57. What is the ratio of the Debt(% of exports of goods, services and primary income) of Sub-Saharan Africa (all income levels) in 2008 to that in 2012?
Keep it short and to the point. 0.72. What is the ratio of the Debt(% of exports of goods, services and primary income) in Albania in 2008 to that in 2012?
Your answer should be compact. 0.62. What is the ratio of the Debt(% of exports of goods, services and primary income) in Jamaica in 2008 to that in 2012?
Offer a terse response. 0.69. What is the ratio of the Debt(% of exports of goods, services and primary income) of Sub-Saharan Africa (all income levels) in 2008 to that in 2013?
Provide a short and direct response. 0.52. What is the ratio of the Debt(% of exports of goods, services and primary income) of Albania in 2008 to that in 2013?
Give a very brief answer. 0.61. What is the ratio of the Debt(% of exports of goods, services and primary income) in Jamaica in 2008 to that in 2013?
Make the answer very short. 0.69. What is the ratio of the Debt(% of exports of goods, services and primary income) of Sub-Saharan Africa (all income levels) in 2009 to that in 2010?
Keep it short and to the point. 1.4. What is the ratio of the Debt(% of exports of goods, services and primary income) in Albania in 2009 to that in 2010?
Offer a terse response. 1.11. What is the ratio of the Debt(% of exports of goods, services and primary income) of Jamaica in 2009 to that in 2010?
Offer a very short reply. 1.49. What is the ratio of the Debt(% of exports of goods, services and primary income) of Sub-Saharan Africa (all income levels) in 2009 to that in 2011?
Make the answer very short. 1.39. What is the ratio of the Debt(% of exports of goods, services and primary income) of Albania in 2009 to that in 2011?
Your answer should be very brief. 0.9. What is the ratio of the Debt(% of exports of goods, services and primary income) of Jamaica in 2009 to that in 2011?
Your answer should be compact. 1.08. What is the ratio of the Debt(% of exports of goods, services and primary income) in Sub-Saharan Africa (all income levels) in 2009 to that in 2012?
Give a very brief answer. 1.01. What is the ratio of the Debt(% of exports of goods, services and primary income) in Albania in 2009 to that in 2012?
Your answer should be very brief. 0.83. What is the ratio of the Debt(% of exports of goods, services and primary income) in Jamaica in 2009 to that in 2012?
Your answer should be very brief. 1.3. What is the ratio of the Debt(% of exports of goods, services and primary income) of Sub-Saharan Africa (all income levels) in 2009 to that in 2013?
Your answer should be very brief. 0.73. What is the ratio of the Debt(% of exports of goods, services and primary income) in Albania in 2009 to that in 2013?
Ensure brevity in your answer.  0.82. What is the ratio of the Debt(% of exports of goods, services and primary income) of Jamaica in 2009 to that in 2013?
Provide a succinct answer. 1.3. What is the ratio of the Debt(% of exports of goods, services and primary income) in Albania in 2010 to that in 2011?
Your response must be concise. 0.81. What is the ratio of the Debt(% of exports of goods, services and primary income) of Jamaica in 2010 to that in 2011?
Make the answer very short. 0.72. What is the ratio of the Debt(% of exports of goods, services and primary income) in Sub-Saharan Africa (all income levels) in 2010 to that in 2012?
Provide a short and direct response. 0.72. What is the ratio of the Debt(% of exports of goods, services and primary income) of Albania in 2010 to that in 2012?
Provide a succinct answer. 0.75. What is the ratio of the Debt(% of exports of goods, services and primary income) of Jamaica in 2010 to that in 2012?
Ensure brevity in your answer.  0.87. What is the ratio of the Debt(% of exports of goods, services and primary income) of Sub-Saharan Africa (all income levels) in 2010 to that in 2013?
Ensure brevity in your answer.  0.52. What is the ratio of the Debt(% of exports of goods, services and primary income) in Albania in 2010 to that in 2013?
Give a very brief answer. 0.74. What is the ratio of the Debt(% of exports of goods, services and primary income) of Jamaica in 2010 to that in 2013?
Ensure brevity in your answer.  0.87. What is the ratio of the Debt(% of exports of goods, services and primary income) in Sub-Saharan Africa (all income levels) in 2011 to that in 2012?
Your answer should be very brief. 0.73. What is the ratio of the Debt(% of exports of goods, services and primary income) of Albania in 2011 to that in 2012?
Make the answer very short. 0.92. What is the ratio of the Debt(% of exports of goods, services and primary income) of Jamaica in 2011 to that in 2012?
Keep it short and to the point. 1.21. What is the ratio of the Debt(% of exports of goods, services and primary income) of Sub-Saharan Africa (all income levels) in 2011 to that in 2013?
Your response must be concise. 0.52. What is the ratio of the Debt(% of exports of goods, services and primary income) in Albania in 2011 to that in 2013?
Your answer should be very brief. 0.91. What is the ratio of the Debt(% of exports of goods, services and primary income) in Jamaica in 2011 to that in 2013?
Offer a terse response. 1.21. What is the ratio of the Debt(% of exports of goods, services and primary income) of Sub-Saharan Africa (all income levels) in 2012 to that in 2013?
Make the answer very short. 0.72. What is the ratio of the Debt(% of exports of goods, services and primary income) in Albania in 2012 to that in 2013?
Ensure brevity in your answer.  0.99. What is the difference between the highest and the second highest Debt(% of exports of goods, services and primary income) of Sub-Saharan Africa (all income levels)?
Your response must be concise. 2.81. What is the difference between the highest and the second highest Debt(% of exports of goods, services and primary income) of Albania?
Provide a short and direct response. 0.07. What is the difference between the highest and the second highest Debt(% of exports of goods, services and primary income) of Jamaica?
Your response must be concise. 2.07. What is the difference between the highest and the lowest Debt(% of exports of goods, services and primary income) of Sub-Saharan Africa (all income levels)?
Keep it short and to the point. 4.99. What is the difference between the highest and the lowest Debt(% of exports of goods, services and primary income) of Albania?
Give a very brief answer. 1.99. What is the difference between the highest and the lowest Debt(% of exports of goods, services and primary income) of Jamaica?
Provide a short and direct response. 15.07. 